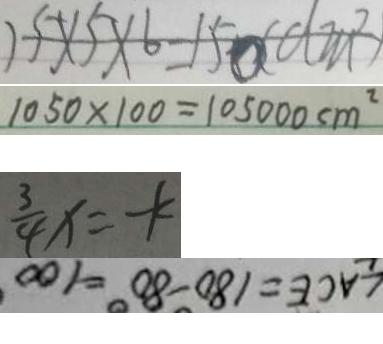Convert formula to latex. <formula><loc_0><loc_0><loc_500><loc_500>1 5 \times 5 \times 6 = 1 5 0 ( d m ^ { 2 } ) 
 1 0 5 0 \times 1 0 0 = 1 0 5 0 0 0 c m ^ { 2 } 
 \frac { 3 } { 4 } x = - k 
 \angle A C E = 1 8 0 ^ { \circ } - 8 0 ^ { \circ } = 1 0 0</formula> 